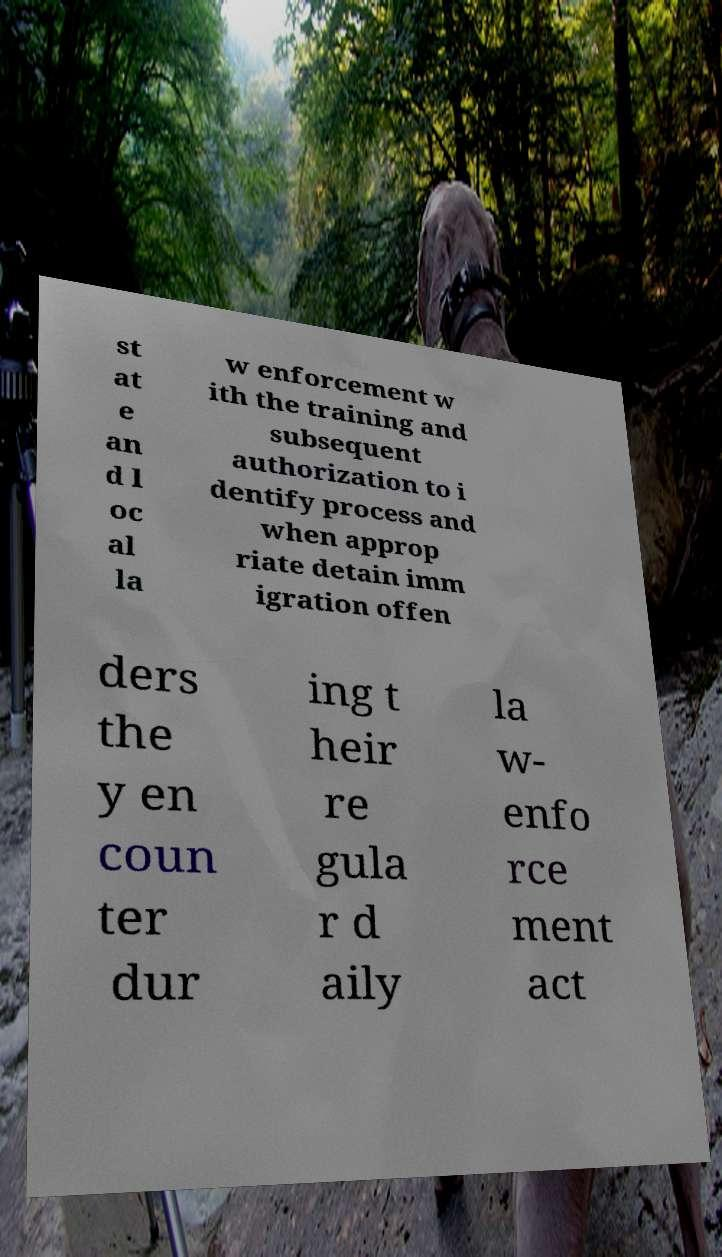What messages or text are displayed in this image? I need them in a readable, typed format. st at e an d l oc al la w enforcement w ith the training and subsequent authorization to i dentify process and when approp riate detain imm igration offen ders the y en coun ter dur ing t heir re gula r d aily la w- enfo rce ment act 